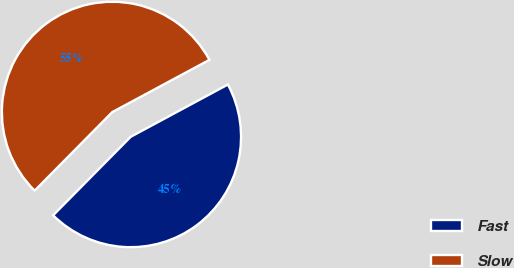Convert chart. <chart><loc_0><loc_0><loc_500><loc_500><pie_chart><fcel>Fast<fcel>Slow<nl><fcel>45.26%<fcel>54.74%<nl></chart> 